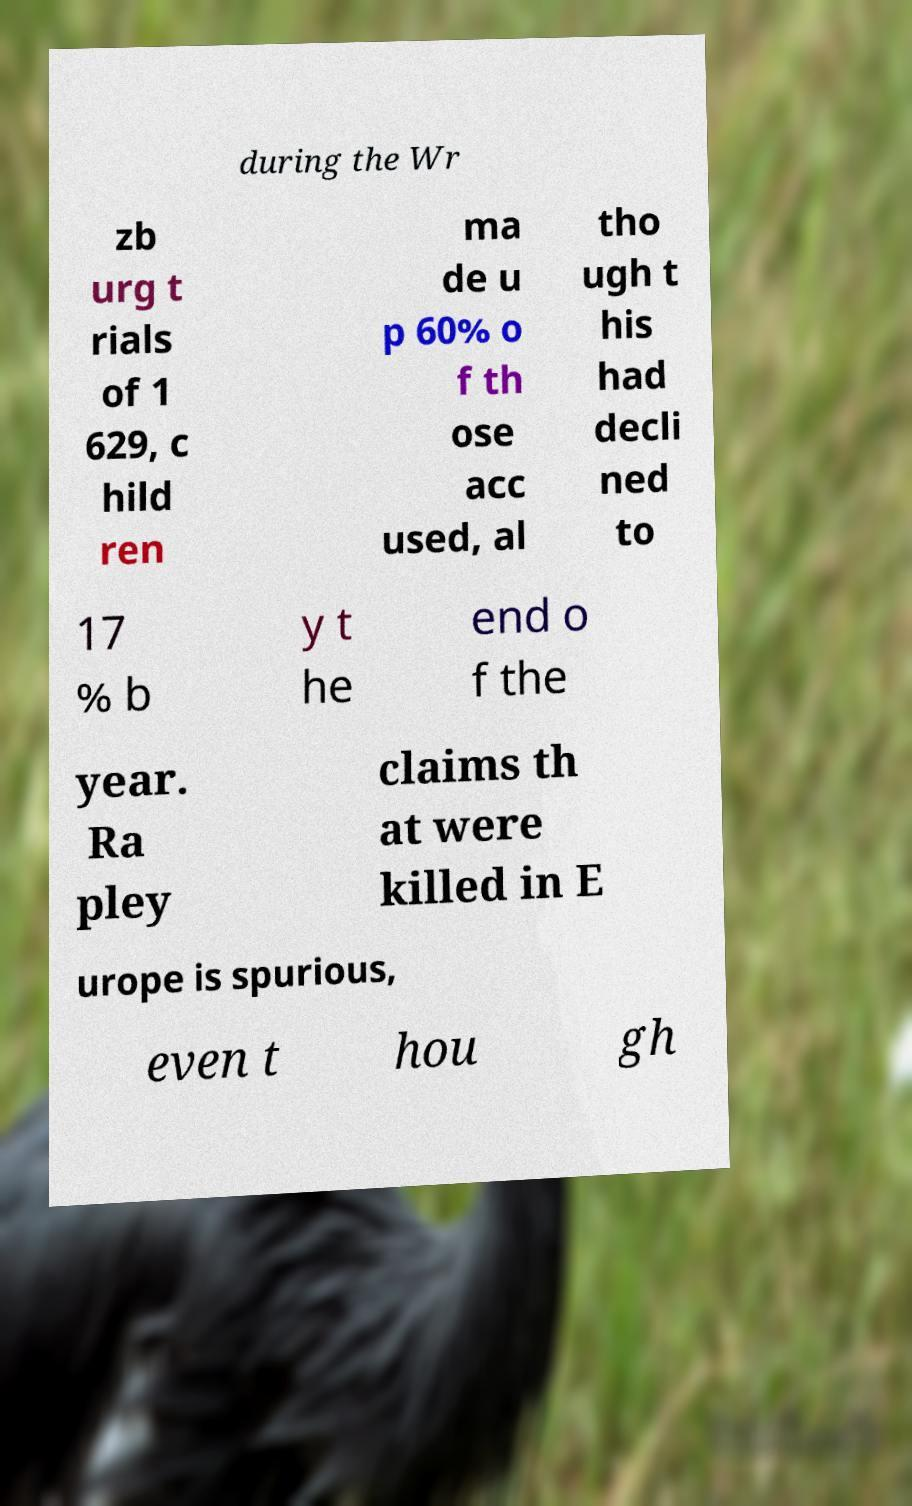Please read and relay the text visible in this image. What does it say? during the Wr zb urg t rials of 1 629, c hild ren ma de u p 60% o f th ose acc used, al tho ugh t his had decli ned to 17 % b y t he end o f the year. Ra pley claims th at were killed in E urope is spurious, even t hou gh 